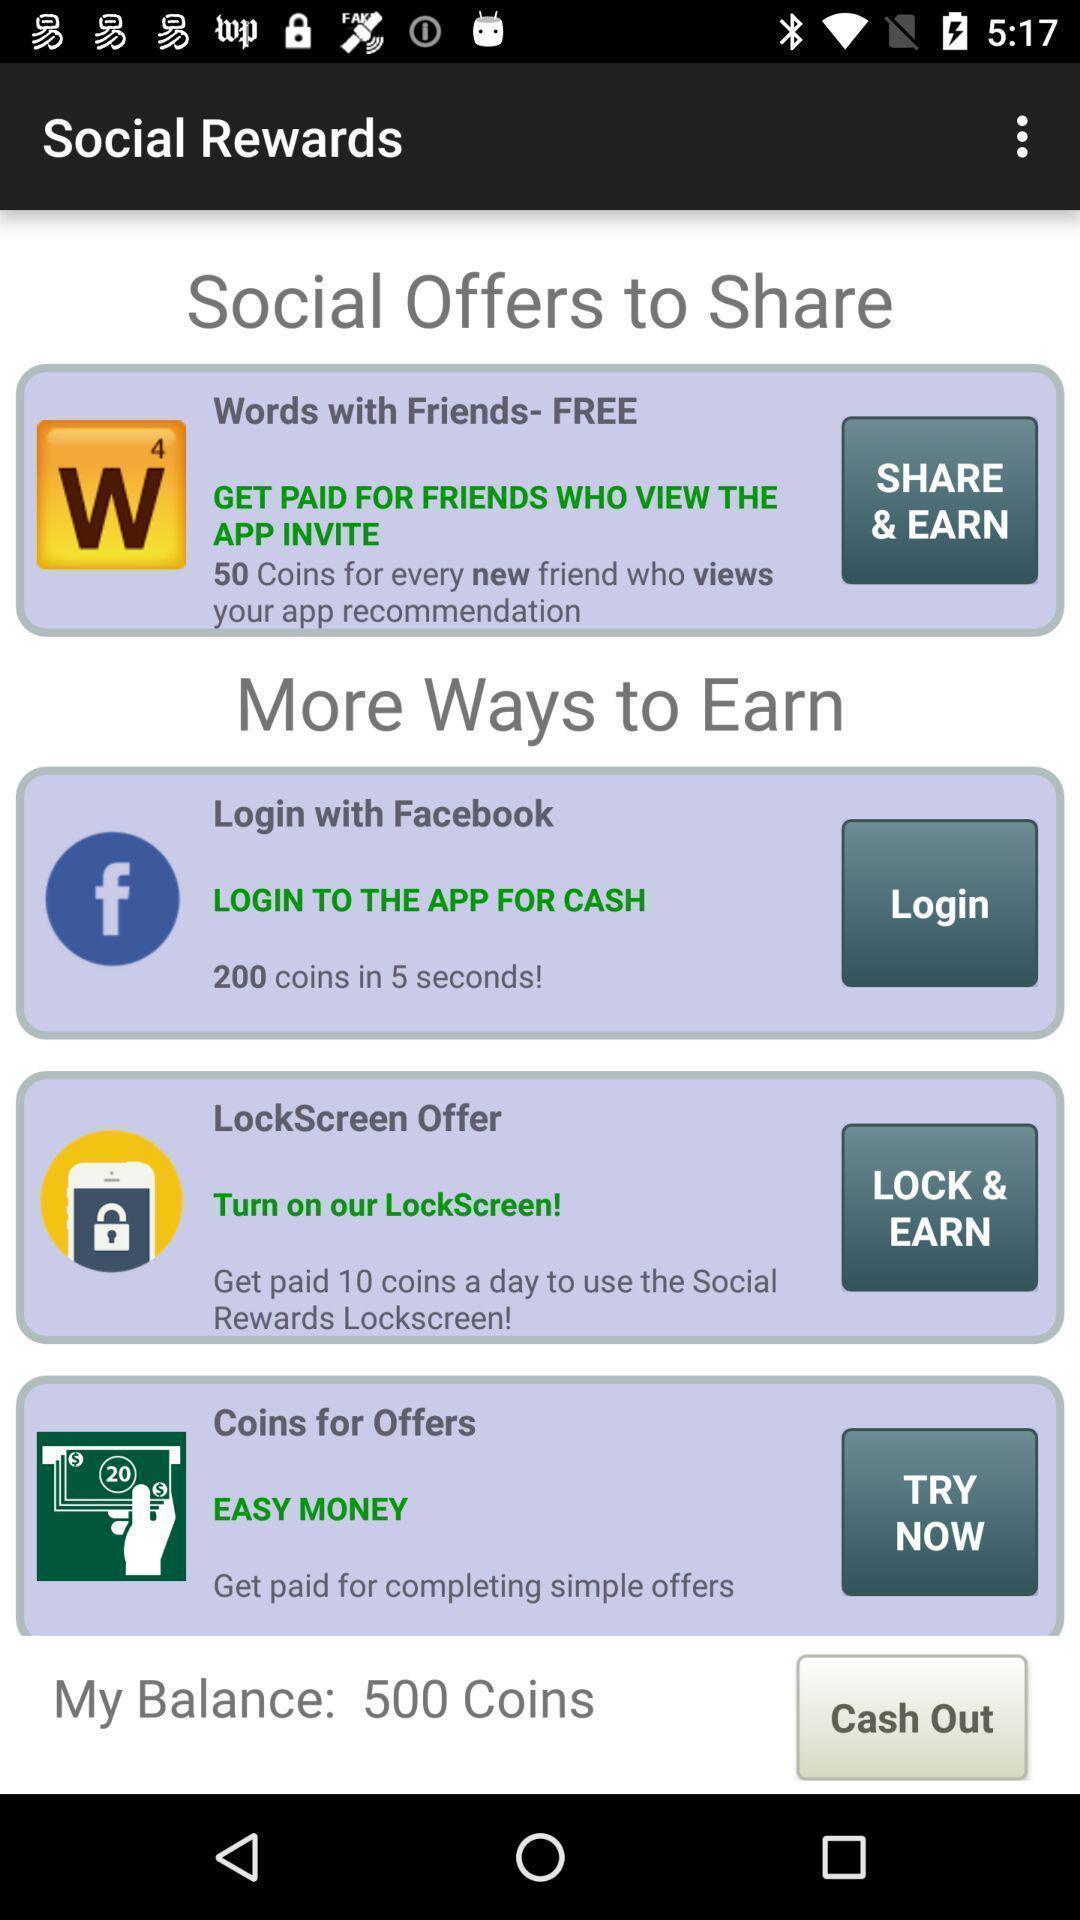Describe this image in words. Screen page displaying various options in financial application. 